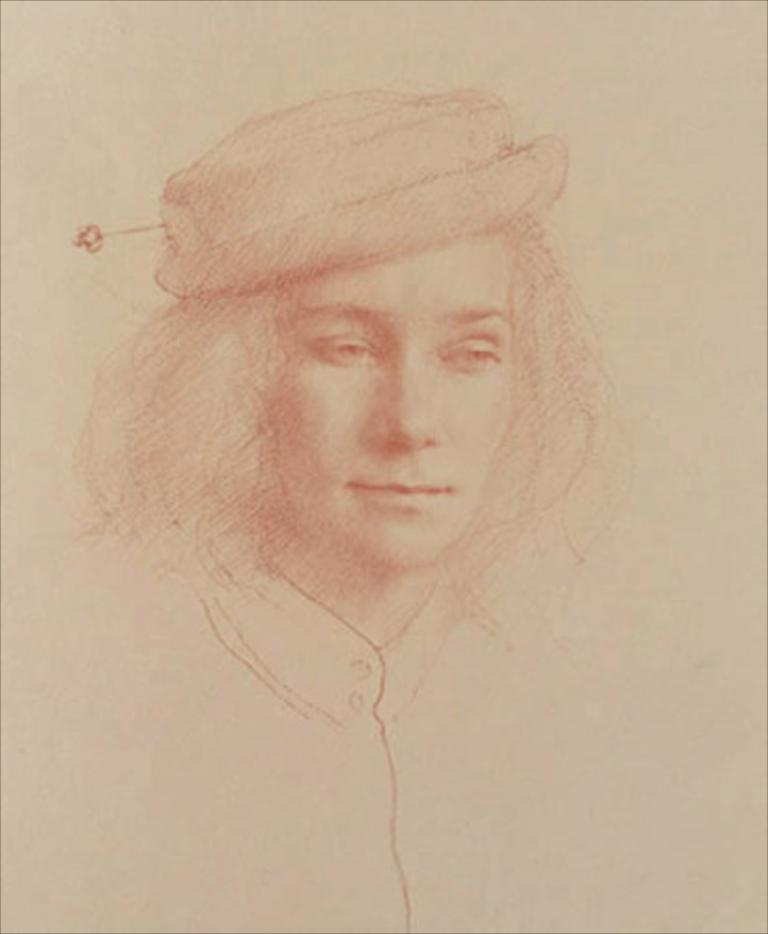What is depicted in the image? There is a sketch of a person in the image. What is the medium of the sketch? The sketch is on a paper. What type of mark can be seen in the image? There is no specific mark mentioned in the facts provided; the image only contains a sketch of a person on a paper. 